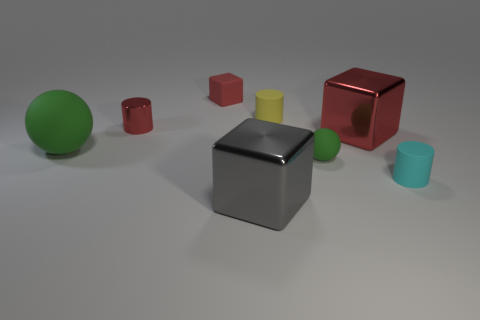Subtract all shiny cubes. How many cubes are left? 1 Add 1 red blocks. How many objects exist? 9 Subtract all red spheres. How many red blocks are left? 2 Subtract all yellow cylinders. How many cylinders are left? 2 Add 5 big spheres. How many big spheres are left? 6 Add 8 tiny purple metal things. How many tiny purple metal things exist? 8 Subtract 0 brown cylinders. How many objects are left? 8 Subtract all cylinders. How many objects are left? 5 Subtract 2 cylinders. How many cylinders are left? 1 Subtract all red blocks. Subtract all brown balls. How many blocks are left? 1 